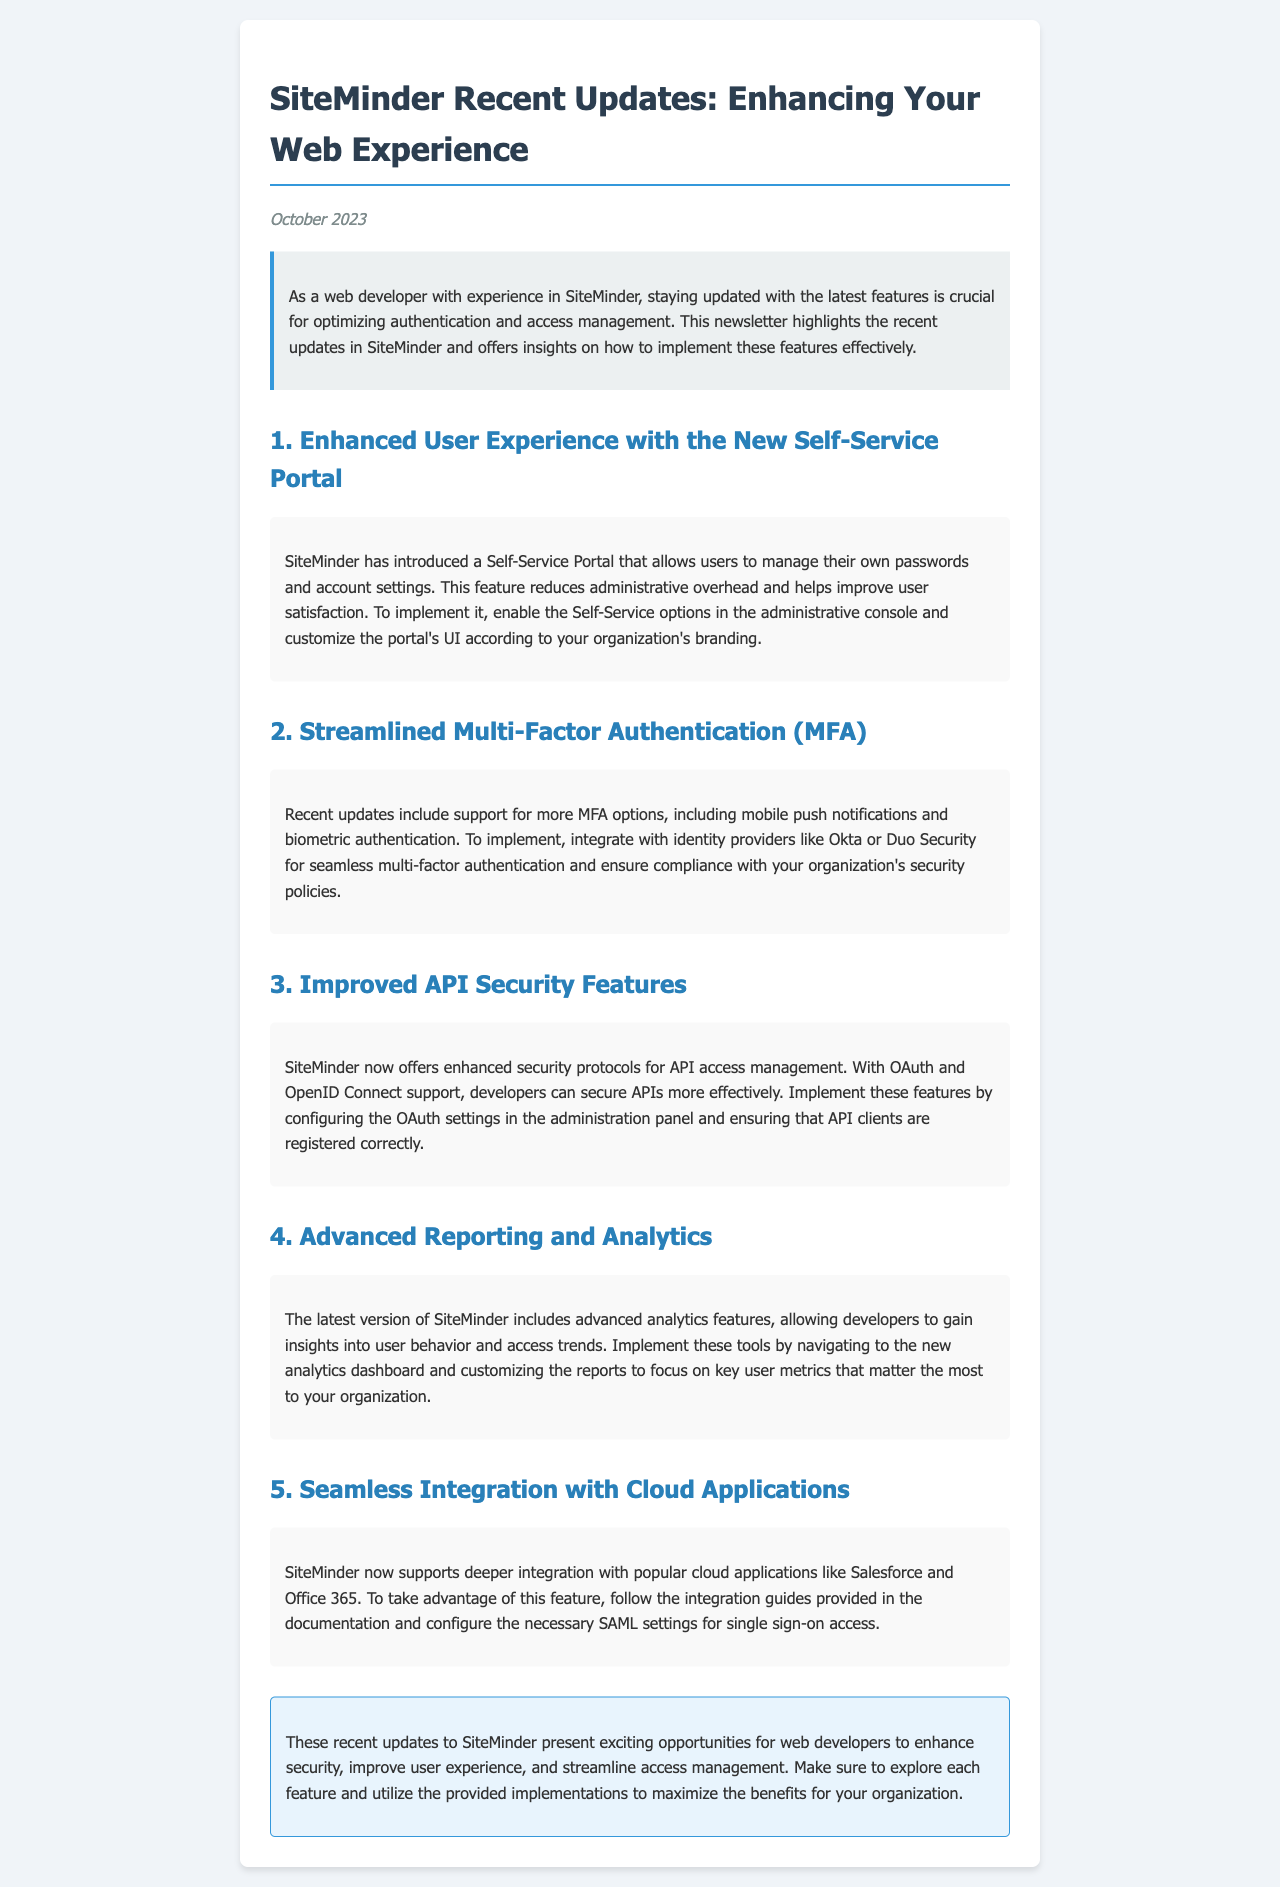What is the date of the newsletter? The date of the newsletter is mentioned in the document under the date heading.
Answer: October 2023 What is the title of the first feature mentioned? The title of the first feature can be found as the first heading under the main title.
Answer: Enhanced User Experience with the New Self-Service Portal How many main features are listed in the newsletter? The document outlines a total of five main features, as numbered in the headings.
Answer: 5 What type of authentication does SiteMinder now support? The document lists multi-factor authentication as a new feature included in the updates.
Answer: Multi-Factor Authentication What tool does SiteMinder use to secure APIs? The document mentions that SiteMinder uses OAuth for API access management.
Answer: OAuth 